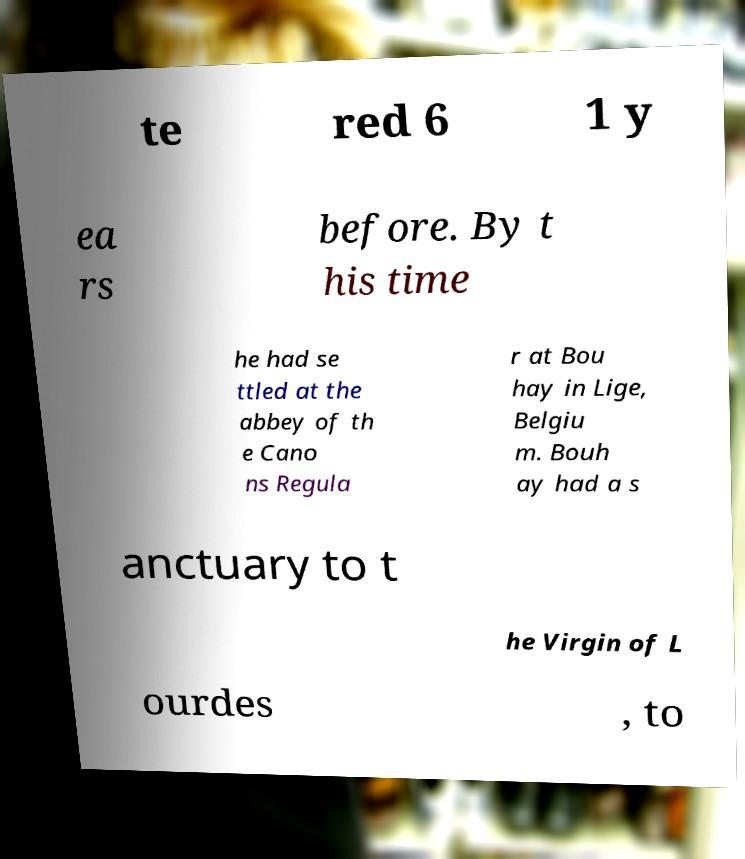There's text embedded in this image that I need extracted. Can you transcribe it verbatim? te red 6 1 y ea rs before. By t his time he had se ttled at the abbey of th e Cano ns Regula r at Bou hay in Lige, Belgiu m. Bouh ay had a s anctuary to t he Virgin of L ourdes , to 